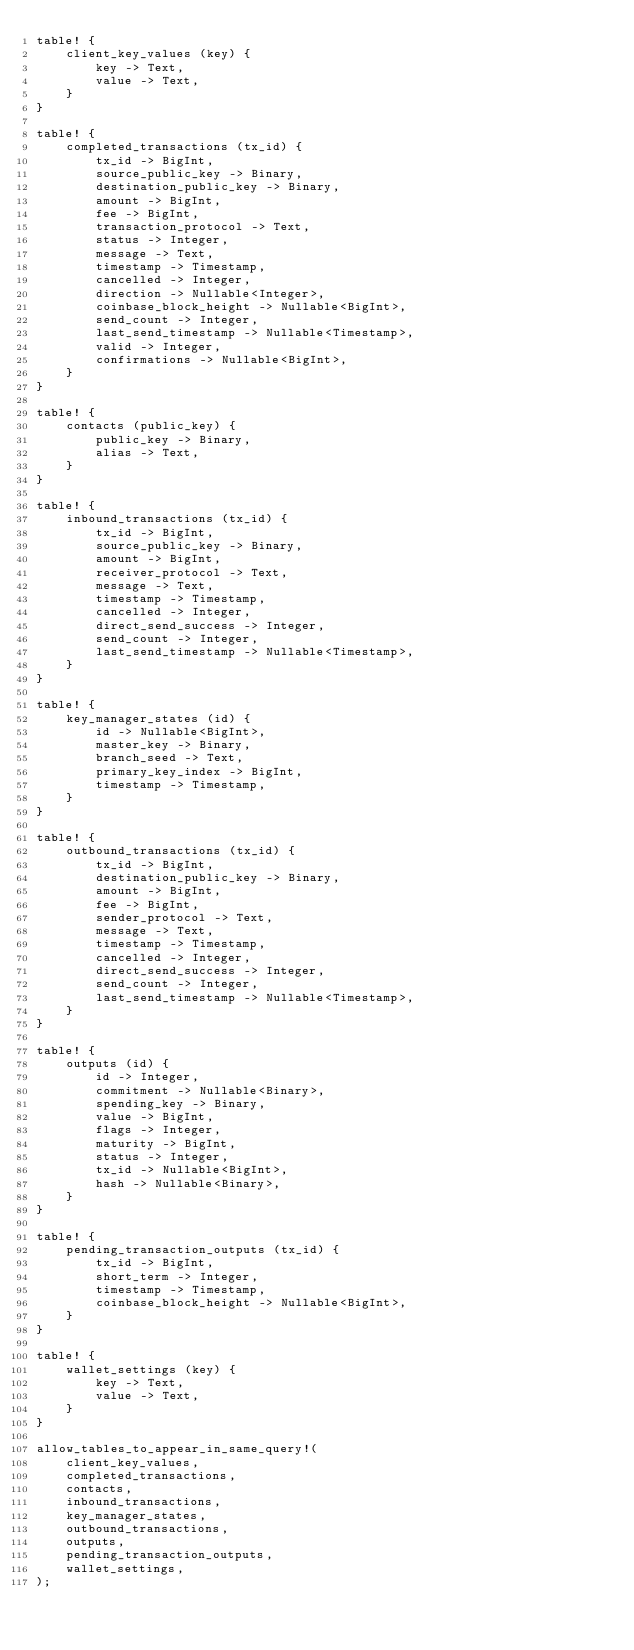Convert code to text. <code><loc_0><loc_0><loc_500><loc_500><_Rust_>table! {
    client_key_values (key) {
        key -> Text,
        value -> Text,
    }
}

table! {
    completed_transactions (tx_id) {
        tx_id -> BigInt,
        source_public_key -> Binary,
        destination_public_key -> Binary,
        amount -> BigInt,
        fee -> BigInt,
        transaction_protocol -> Text,
        status -> Integer,
        message -> Text,
        timestamp -> Timestamp,
        cancelled -> Integer,
        direction -> Nullable<Integer>,
        coinbase_block_height -> Nullable<BigInt>,
        send_count -> Integer,
        last_send_timestamp -> Nullable<Timestamp>,
        valid -> Integer,
        confirmations -> Nullable<BigInt>,
    }
}

table! {
    contacts (public_key) {
        public_key -> Binary,
        alias -> Text,
    }
}

table! {
    inbound_transactions (tx_id) {
        tx_id -> BigInt,
        source_public_key -> Binary,
        amount -> BigInt,
        receiver_protocol -> Text,
        message -> Text,
        timestamp -> Timestamp,
        cancelled -> Integer,
        direct_send_success -> Integer,
        send_count -> Integer,
        last_send_timestamp -> Nullable<Timestamp>,
    }
}

table! {
    key_manager_states (id) {
        id -> Nullable<BigInt>,
        master_key -> Binary,
        branch_seed -> Text,
        primary_key_index -> BigInt,
        timestamp -> Timestamp,
    }
}

table! {
    outbound_transactions (tx_id) {
        tx_id -> BigInt,
        destination_public_key -> Binary,
        amount -> BigInt,
        fee -> BigInt,
        sender_protocol -> Text,
        message -> Text,
        timestamp -> Timestamp,
        cancelled -> Integer,
        direct_send_success -> Integer,
        send_count -> Integer,
        last_send_timestamp -> Nullable<Timestamp>,
    }
}

table! {
    outputs (id) {
        id -> Integer,
        commitment -> Nullable<Binary>,
        spending_key -> Binary,
        value -> BigInt,
        flags -> Integer,
        maturity -> BigInt,
        status -> Integer,
        tx_id -> Nullable<BigInt>,
        hash -> Nullable<Binary>,
    }
}

table! {
    pending_transaction_outputs (tx_id) {
        tx_id -> BigInt,
        short_term -> Integer,
        timestamp -> Timestamp,
        coinbase_block_height -> Nullable<BigInt>,
    }
}

table! {
    wallet_settings (key) {
        key -> Text,
        value -> Text,
    }
}

allow_tables_to_appear_in_same_query!(
    client_key_values,
    completed_transactions,
    contacts,
    inbound_transactions,
    key_manager_states,
    outbound_transactions,
    outputs,
    pending_transaction_outputs,
    wallet_settings,
);
</code> 